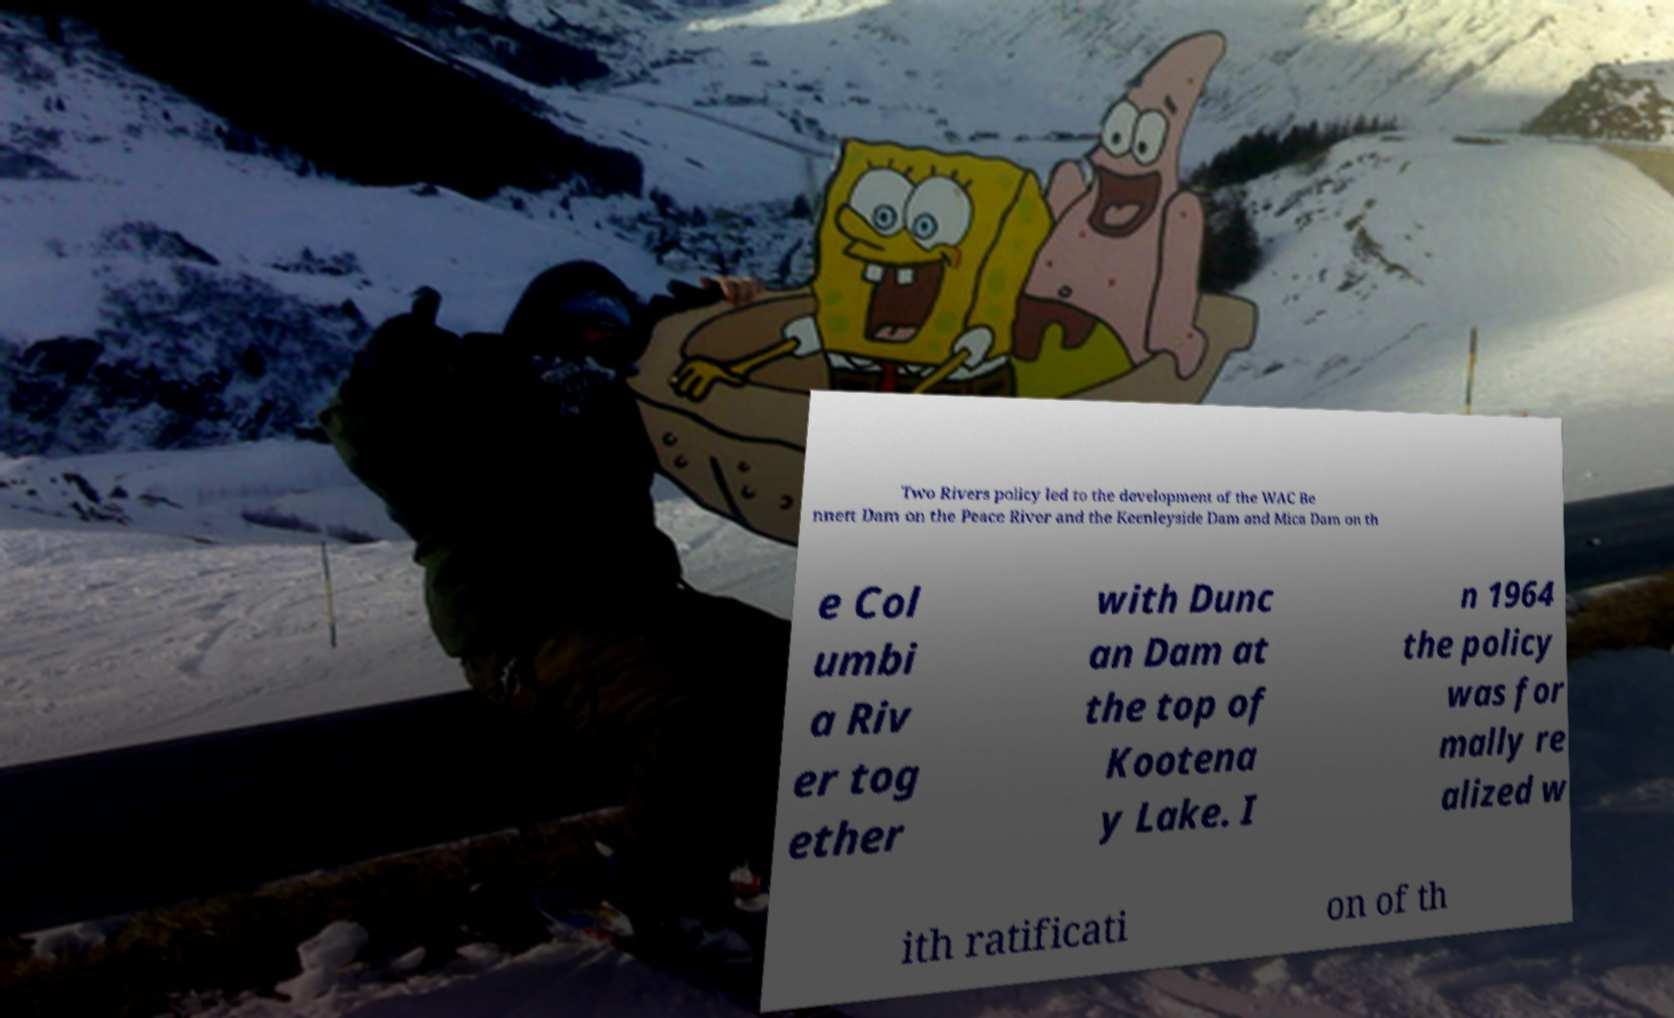Can you read and provide the text displayed in the image?This photo seems to have some interesting text. Can you extract and type it out for me? Two Rivers policy led to the development of the WAC Be nnett Dam on the Peace River and the Keenleyside Dam and Mica Dam on th e Col umbi a Riv er tog ether with Dunc an Dam at the top of Kootena y Lake. I n 1964 the policy was for mally re alized w ith ratificati on of th 